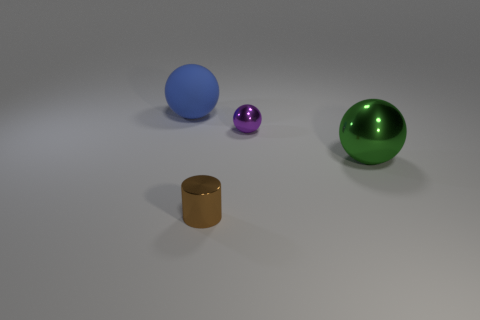Add 3 blue matte spheres. How many objects exist? 7 Subtract all metallic spheres. How many spheres are left? 1 Add 4 big cyan metal spheres. How many big cyan metal spheres exist? 4 Subtract all green spheres. How many spheres are left? 2 Subtract 0 cyan blocks. How many objects are left? 4 Subtract all balls. How many objects are left? 1 Subtract 1 cylinders. How many cylinders are left? 0 Subtract all gray balls. Subtract all green blocks. How many balls are left? 3 Subtract all yellow cylinders. How many gray spheres are left? 0 Subtract all large rubber objects. Subtract all shiny spheres. How many objects are left? 1 